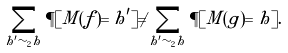<formula> <loc_0><loc_0><loc_500><loc_500>\sum _ { h ^ { \prime } \sim _ { 2 } h } \P [ M ( f ) = h ^ { \prime } ] \neq \sum _ { h ^ { \prime } \sim _ { 2 } h } \P [ M ( g ) = h ] .</formula> 